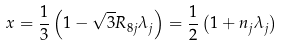Convert formula to latex. <formula><loc_0><loc_0><loc_500><loc_500>x = \frac { 1 } { 3 } \left ( { 1 - \sqrt { 3 } { R _ { 8 j } } { \lambda _ { j } } } \right ) = \frac { 1 } { 2 } \left ( { 1 + { n _ { j } } { \lambda _ { j } } } \right )</formula> 